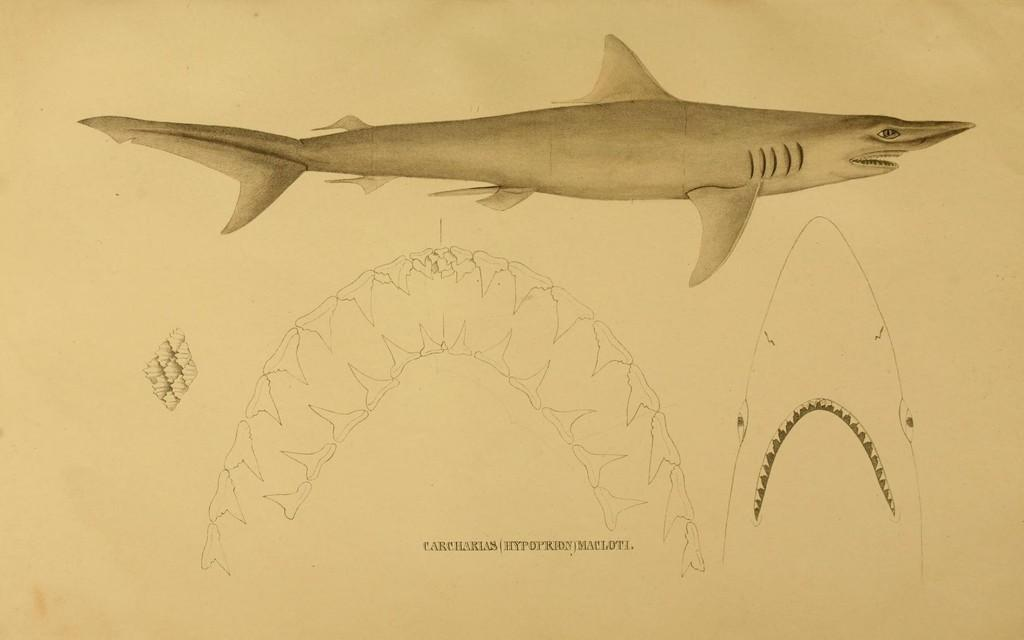What is the main subject of the image? There is a depiction of a shark in the image. What type of pump is being used by the goose in the image? There is no goose or pump present in the image; it only features a depiction of a shark. 